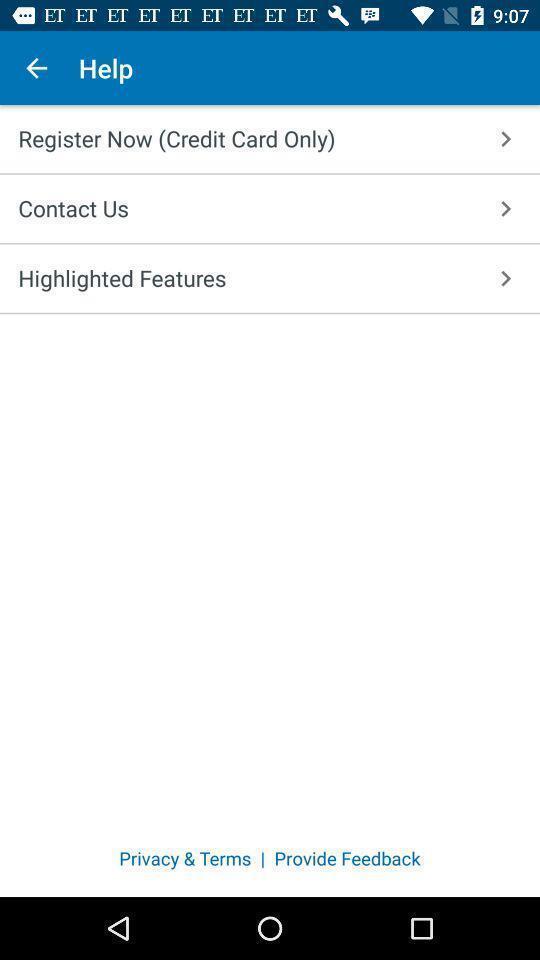What can you discern from this picture? Page with help options for a credit card app. 